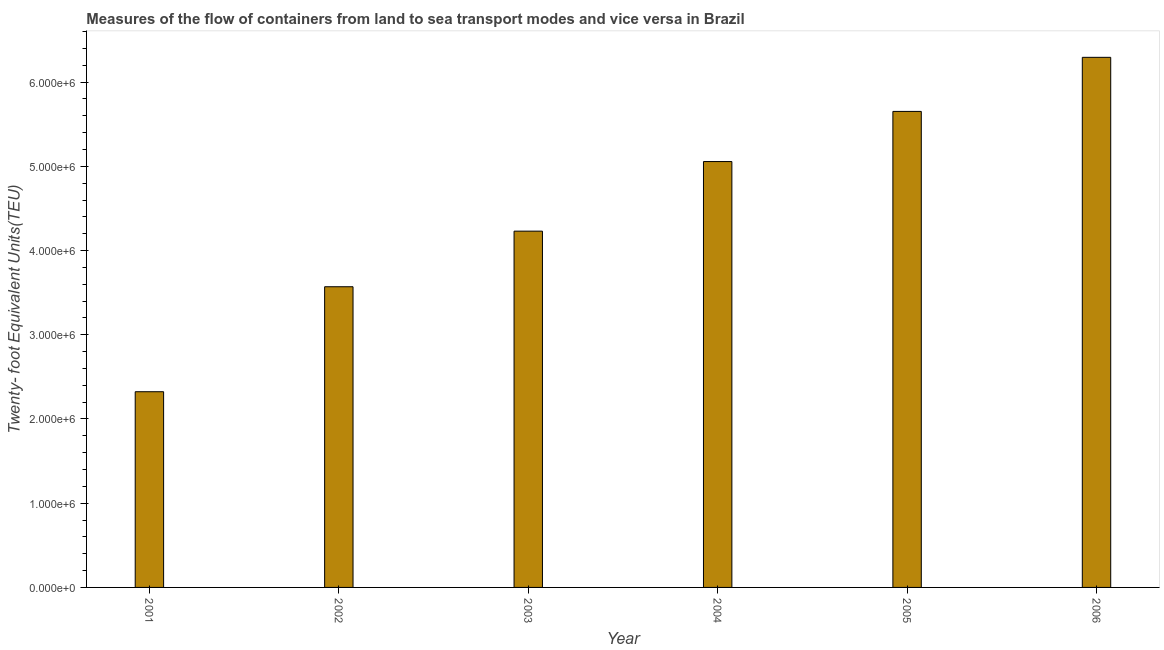Does the graph contain grids?
Provide a succinct answer. No. What is the title of the graph?
Keep it short and to the point. Measures of the flow of containers from land to sea transport modes and vice versa in Brazil. What is the label or title of the X-axis?
Offer a very short reply. Year. What is the label or title of the Y-axis?
Your answer should be very brief. Twenty- foot Equivalent Units(TEU). What is the container port traffic in 2004?
Your answer should be compact. 5.06e+06. Across all years, what is the maximum container port traffic?
Your response must be concise. 6.29e+06. Across all years, what is the minimum container port traffic?
Ensure brevity in your answer.  2.32e+06. In which year was the container port traffic maximum?
Make the answer very short. 2006. In which year was the container port traffic minimum?
Your answer should be compact. 2001. What is the sum of the container port traffic?
Your answer should be compact. 2.71e+07. What is the difference between the container port traffic in 2001 and 2006?
Your answer should be very brief. -3.97e+06. What is the average container port traffic per year?
Provide a succinct answer. 4.52e+06. What is the median container port traffic?
Offer a terse response. 4.64e+06. In how many years, is the container port traffic greater than 1000000 TEU?
Offer a terse response. 6. What is the ratio of the container port traffic in 2004 to that in 2006?
Keep it short and to the point. 0.8. What is the difference between the highest and the second highest container port traffic?
Your answer should be compact. 6.42e+05. What is the difference between the highest and the lowest container port traffic?
Your answer should be very brief. 3.97e+06. How many bars are there?
Ensure brevity in your answer.  6. How many years are there in the graph?
Provide a short and direct response. 6. What is the Twenty- foot Equivalent Units(TEU) in 2001?
Provide a short and direct response. 2.32e+06. What is the Twenty- foot Equivalent Units(TEU) in 2002?
Make the answer very short. 3.57e+06. What is the Twenty- foot Equivalent Units(TEU) of 2003?
Your answer should be compact. 4.23e+06. What is the Twenty- foot Equivalent Units(TEU) of 2004?
Your answer should be compact. 5.06e+06. What is the Twenty- foot Equivalent Units(TEU) of 2005?
Make the answer very short. 5.65e+06. What is the Twenty- foot Equivalent Units(TEU) in 2006?
Give a very brief answer. 6.29e+06. What is the difference between the Twenty- foot Equivalent Units(TEU) in 2001 and 2002?
Your response must be concise. -1.25e+06. What is the difference between the Twenty- foot Equivalent Units(TEU) in 2001 and 2003?
Ensure brevity in your answer.  -1.91e+06. What is the difference between the Twenty- foot Equivalent Units(TEU) in 2001 and 2004?
Offer a terse response. -2.73e+06. What is the difference between the Twenty- foot Equivalent Units(TEU) in 2001 and 2005?
Your answer should be very brief. -3.33e+06. What is the difference between the Twenty- foot Equivalent Units(TEU) in 2001 and 2006?
Your response must be concise. -3.97e+06. What is the difference between the Twenty- foot Equivalent Units(TEU) in 2002 and 2003?
Make the answer very short. -6.60e+05. What is the difference between the Twenty- foot Equivalent Units(TEU) in 2002 and 2004?
Ensure brevity in your answer.  -1.49e+06. What is the difference between the Twenty- foot Equivalent Units(TEU) in 2002 and 2005?
Provide a succinct answer. -2.08e+06. What is the difference between the Twenty- foot Equivalent Units(TEU) in 2002 and 2006?
Offer a very short reply. -2.72e+06. What is the difference between the Twenty- foot Equivalent Units(TEU) in 2003 and 2004?
Provide a short and direct response. -8.26e+05. What is the difference between the Twenty- foot Equivalent Units(TEU) in 2003 and 2005?
Give a very brief answer. -1.42e+06. What is the difference between the Twenty- foot Equivalent Units(TEU) in 2003 and 2006?
Keep it short and to the point. -2.06e+06. What is the difference between the Twenty- foot Equivalent Units(TEU) in 2004 and 2005?
Provide a short and direct response. -5.95e+05. What is the difference between the Twenty- foot Equivalent Units(TEU) in 2004 and 2006?
Ensure brevity in your answer.  -1.24e+06. What is the difference between the Twenty- foot Equivalent Units(TEU) in 2005 and 2006?
Your answer should be very brief. -6.42e+05. What is the ratio of the Twenty- foot Equivalent Units(TEU) in 2001 to that in 2002?
Provide a succinct answer. 0.65. What is the ratio of the Twenty- foot Equivalent Units(TEU) in 2001 to that in 2003?
Your answer should be very brief. 0.55. What is the ratio of the Twenty- foot Equivalent Units(TEU) in 2001 to that in 2004?
Offer a very short reply. 0.46. What is the ratio of the Twenty- foot Equivalent Units(TEU) in 2001 to that in 2005?
Provide a short and direct response. 0.41. What is the ratio of the Twenty- foot Equivalent Units(TEU) in 2001 to that in 2006?
Your answer should be compact. 0.37. What is the ratio of the Twenty- foot Equivalent Units(TEU) in 2002 to that in 2003?
Offer a very short reply. 0.84. What is the ratio of the Twenty- foot Equivalent Units(TEU) in 2002 to that in 2004?
Give a very brief answer. 0.71. What is the ratio of the Twenty- foot Equivalent Units(TEU) in 2002 to that in 2005?
Offer a very short reply. 0.63. What is the ratio of the Twenty- foot Equivalent Units(TEU) in 2002 to that in 2006?
Your answer should be compact. 0.57. What is the ratio of the Twenty- foot Equivalent Units(TEU) in 2003 to that in 2004?
Keep it short and to the point. 0.84. What is the ratio of the Twenty- foot Equivalent Units(TEU) in 2003 to that in 2005?
Your answer should be compact. 0.75. What is the ratio of the Twenty- foot Equivalent Units(TEU) in 2003 to that in 2006?
Offer a very short reply. 0.67. What is the ratio of the Twenty- foot Equivalent Units(TEU) in 2004 to that in 2005?
Ensure brevity in your answer.  0.9. What is the ratio of the Twenty- foot Equivalent Units(TEU) in 2004 to that in 2006?
Give a very brief answer. 0.8. What is the ratio of the Twenty- foot Equivalent Units(TEU) in 2005 to that in 2006?
Provide a short and direct response. 0.9. 